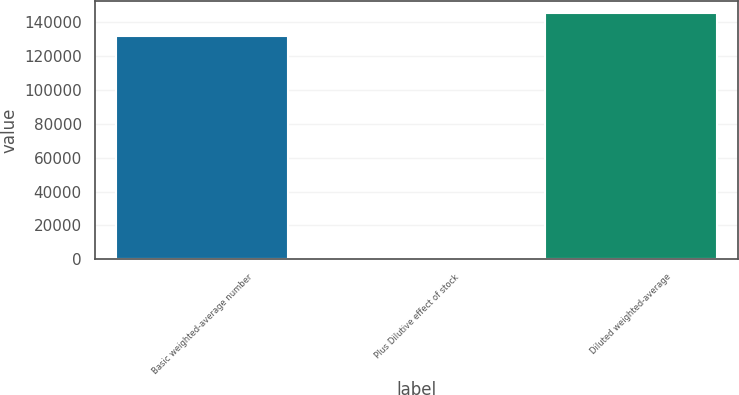<chart> <loc_0><loc_0><loc_500><loc_500><bar_chart><fcel>Basic weighted-average number<fcel>Plus Dilutive effect of stock<fcel>Diluted weighted-average<nl><fcel>132284<fcel>883<fcel>145512<nl></chart> 